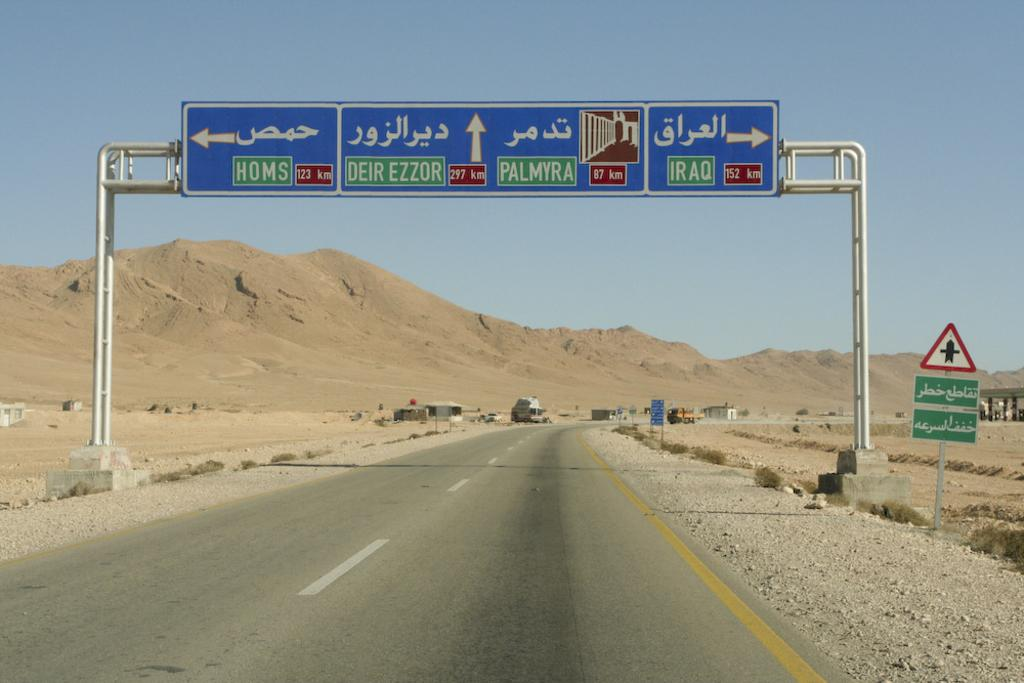<image>
Create a compact narrative representing the image presented. Highway signs including one that leads to IRAQ. 